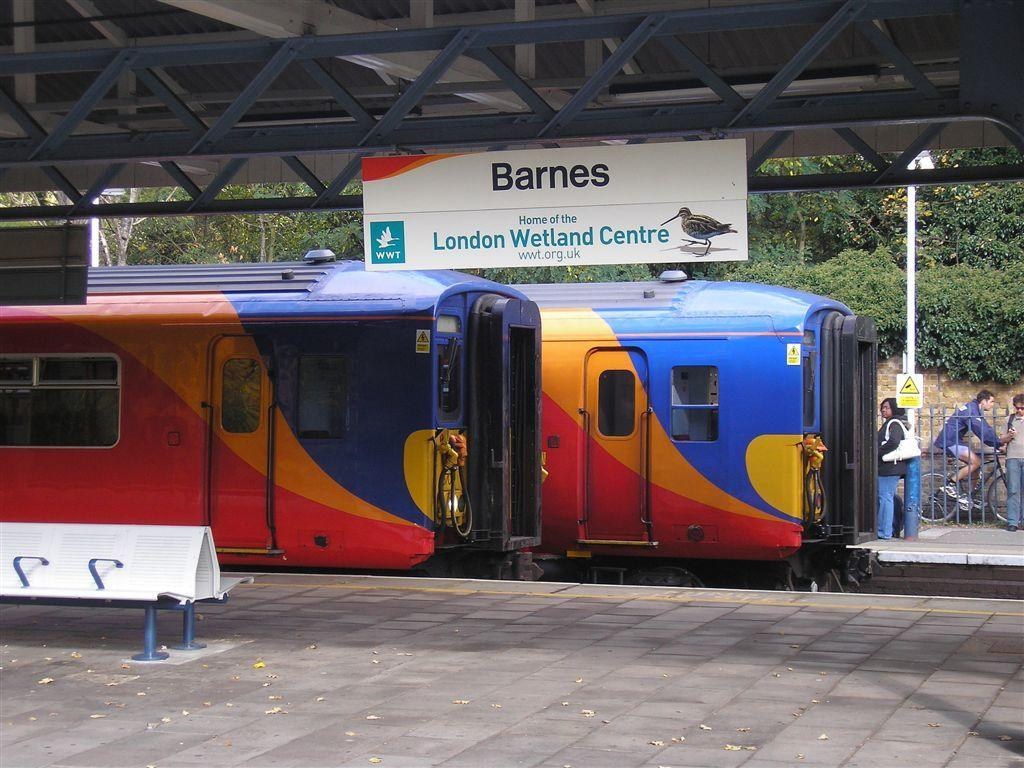<image>
Give a short and clear explanation of the subsequent image. A train with the banner Barnes and home of the London Wetland Centre. 